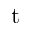<formula> <loc_0><loc_0><loc_500><loc_500>t</formula> 